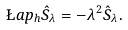Convert formula to latex. <formula><loc_0><loc_0><loc_500><loc_500>\L a p _ { h } \hat { S } _ { \lambda } = - \lambda ^ { 2 } \hat { S } _ { \lambda } .</formula> 